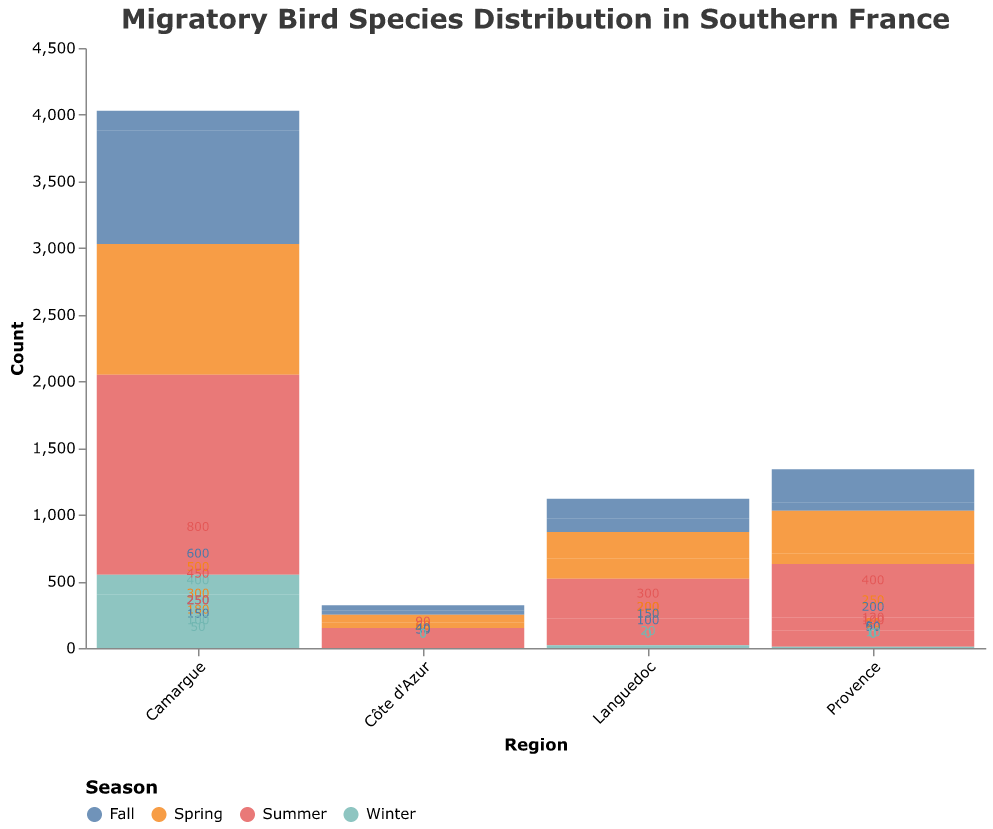How many bird species are observed in Provence during Spring? Look at the data provided for Provence in the Spring column and count the number of species with non-zero values. There are three species: European Bee-eater, Eurasian Hoopoe, Common Swift.
Answer: 3 Which bird species has the highest count in Summer in the Camargue region? Refer to the data for the Camargue region during Summer and observe the bird species counts. The species with the highest count is the Greater Flamingo with 800.
Answer: Greater Flamingo What is the total count of Barn Swallows across all seasons in Languedoc? Sum the seasonal counts for Barn Swallows in Languedoc: 200 (Spring) + 300 (Summer) + 150 (Fall) + 0 (Winter). The total is 650.
Answer: 650 In which season do European Turtle Doves appear in Côte d'Azur? Examine the seasonal distribution for European Turtle Doves in Côte d'Azur. They appear in Spring, Summer, and Fall but not in Winter.
Answer: Spring, Summer, Fall Compare the Spring counts of Common Swifts between Provence and Camargue. Which region has a higher count? Look at the data for the Spring count of Common Swifts in both regions: Provence has 250 and Camargue does not have Common Swifts listed. Provence has the higher count.
Answer: Provence What is the average count of Black-winged Stilts in Camargue across all seasons? Calculate the average by summing the seasonal counts for Black-winged Stilts (300 + 450 + 250 + 50) and dividing by 4. The total is 1050, and the average is 1050 / 4 = 262.5.
Answer: 262.5 Which species has the lowest count in Winter in the Languedoc region? Refer to the Winter column for the Languedoc region and check the counts. The species with the lowest count is the White Stork with 20.
Answer: White Stork How does the number of migratory bird species change from Fall to Winter in Provence? Compare the number of species with non-zero values in Fall and Winter for Provence. In Fall, there are three species (European Bee-eater, Eurasian Hoopoe, Common Swift), and in Winter, there is one species (Eurasian Hoopoe). Therefore, the number of species decreases by 2.
Answer: Decreases by 2 Which season has the highest total bird count in the Camargue region? Sum the species counts for each season in the Camargue region: Spring (500+300+180) = 980, Summer (800+450+250) = 1500, Fall (600+250+150) = 1000, Winter (400+50+100) = 550. Summer has the highest total count.
Answer: Summer 